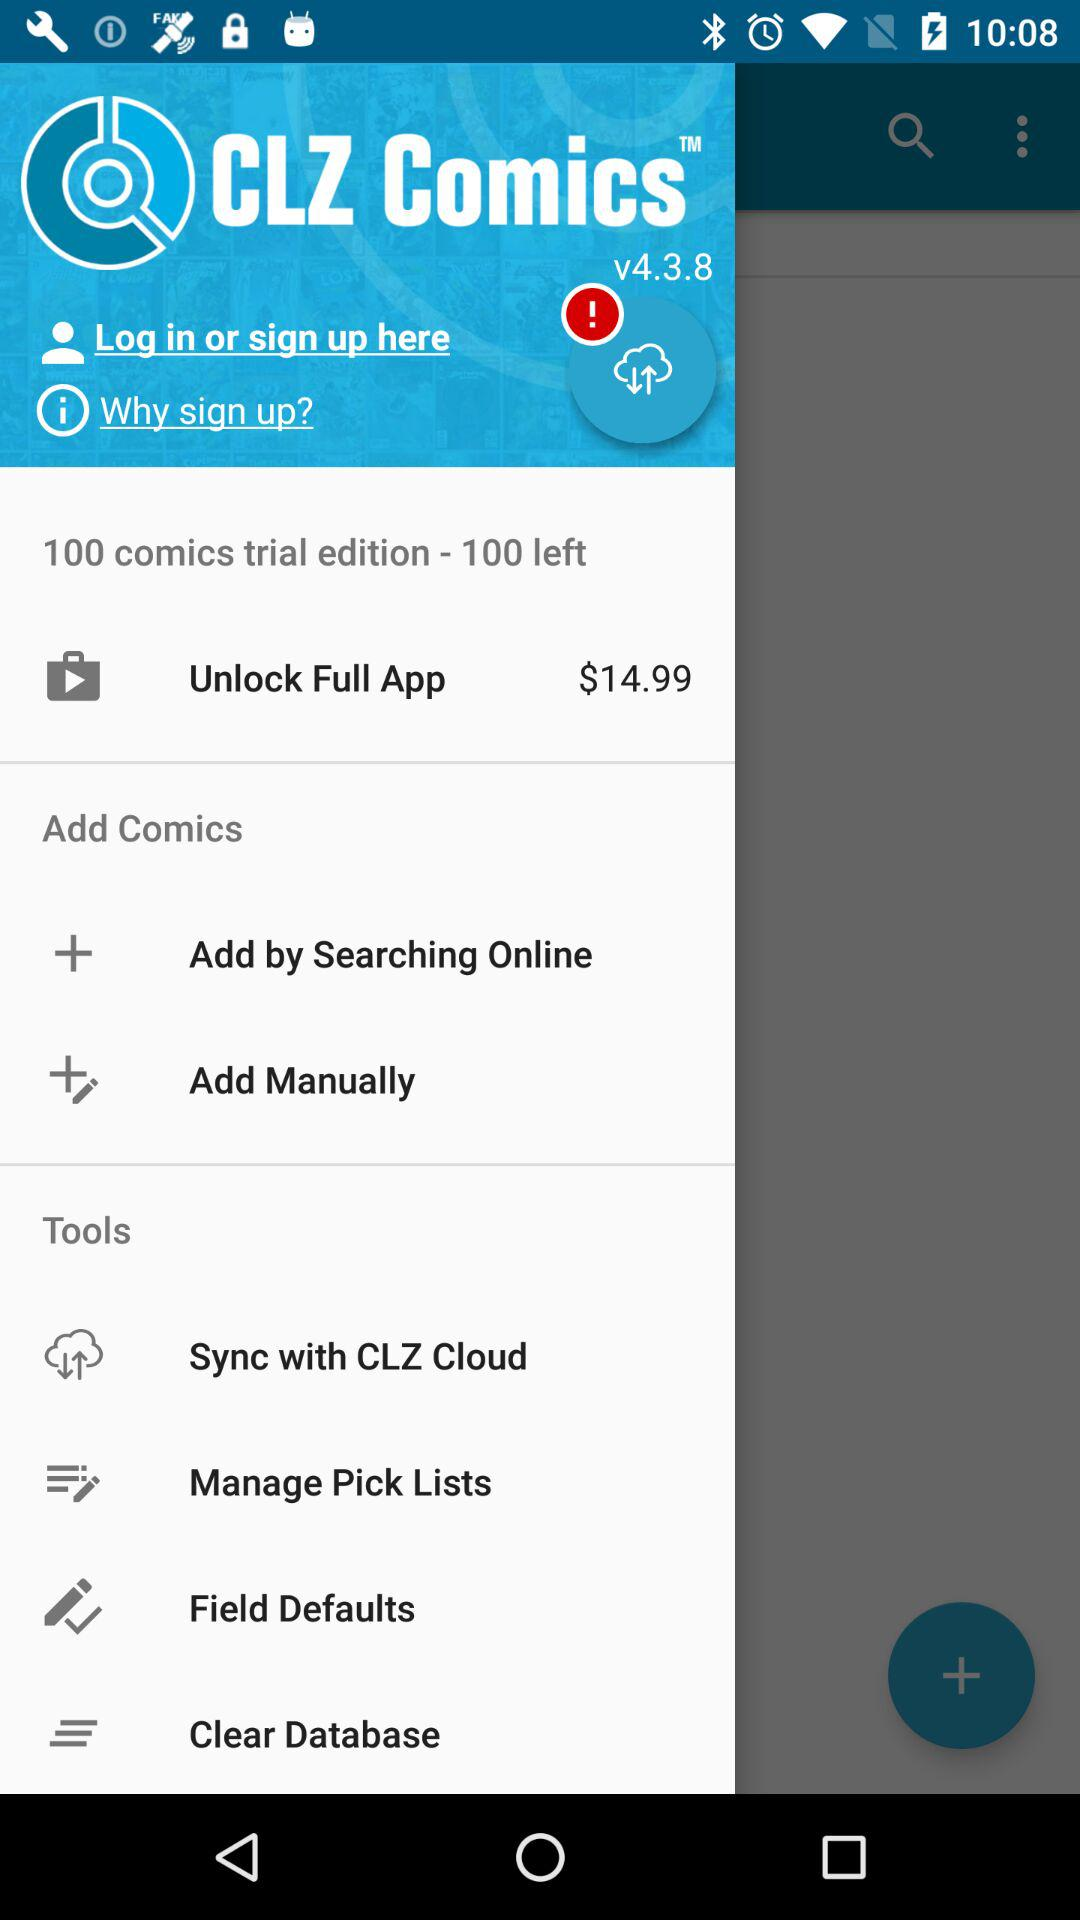Which version of the application is shown? The shown version of the application is v4.3.8. 